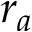Convert formula to latex. <formula><loc_0><loc_0><loc_500><loc_500>r _ { a }</formula> 